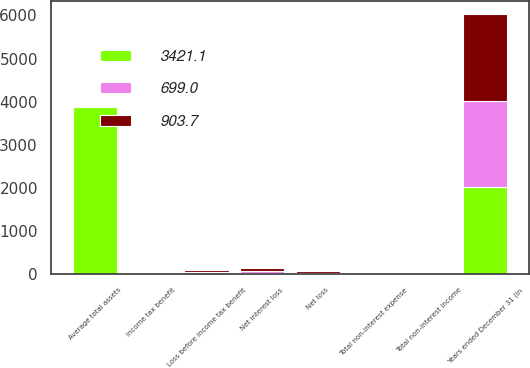Convert chart to OTSL. <chart><loc_0><loc_0><loc_500><loc_500><stacked_bar_chart><ecel><fcel>Years ended December 31 (in<fcel>Net interest loss<fcel>Total non-interest income<fcel>Total non-interest expense<fcel>Loss before income tax benefit<fcel>Income tax benefit<fcel>Net loss<fcel>Average total assets<nl><fcel>699<fcel>2013<fcel>46.5<fcel>18<fcel>1.2<fcel>27.3<fcel>8.7<fcel>18.6<fcel>18.3<nl><fcel>903.7<fcel>2012<fcel>66<fcel>10.6<fcel>3.3<fcel>52.1<fcel>17<fcel>35.1<fcel>18.3<nl><fcel>3421.1<fcel>2011<fcel>21.1<fcel>14<fcel>1.3<fcel>5.8<fcel>1.6<fcel>4.2<fcel>3870.3<nl></chart> 